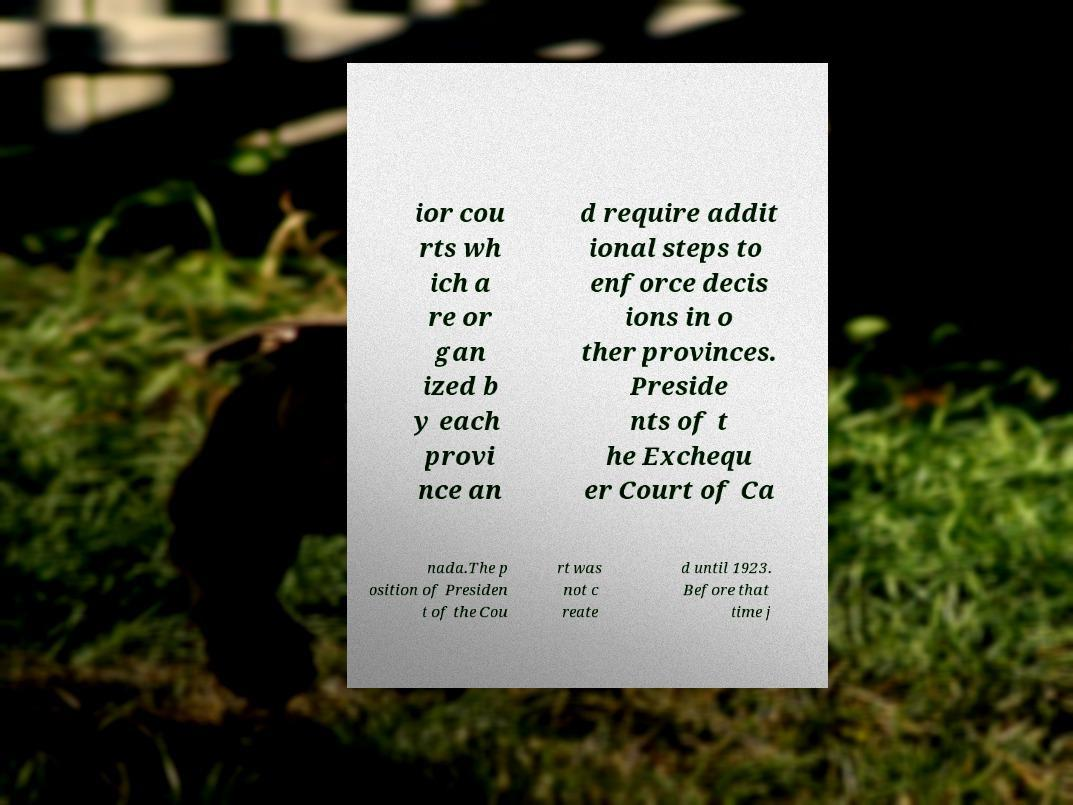Please identify and transcribe the text found in this image. ior cou rts wh ich a re or gan ized b y each provi nce an d require addit ional steps to enforce decis ions in o ther provinces. Preside nts of t he Exchequ er Court of Ca nada.The p osition of Presiden t of the Cou rt was not c reate d until 1923. Before that time j 